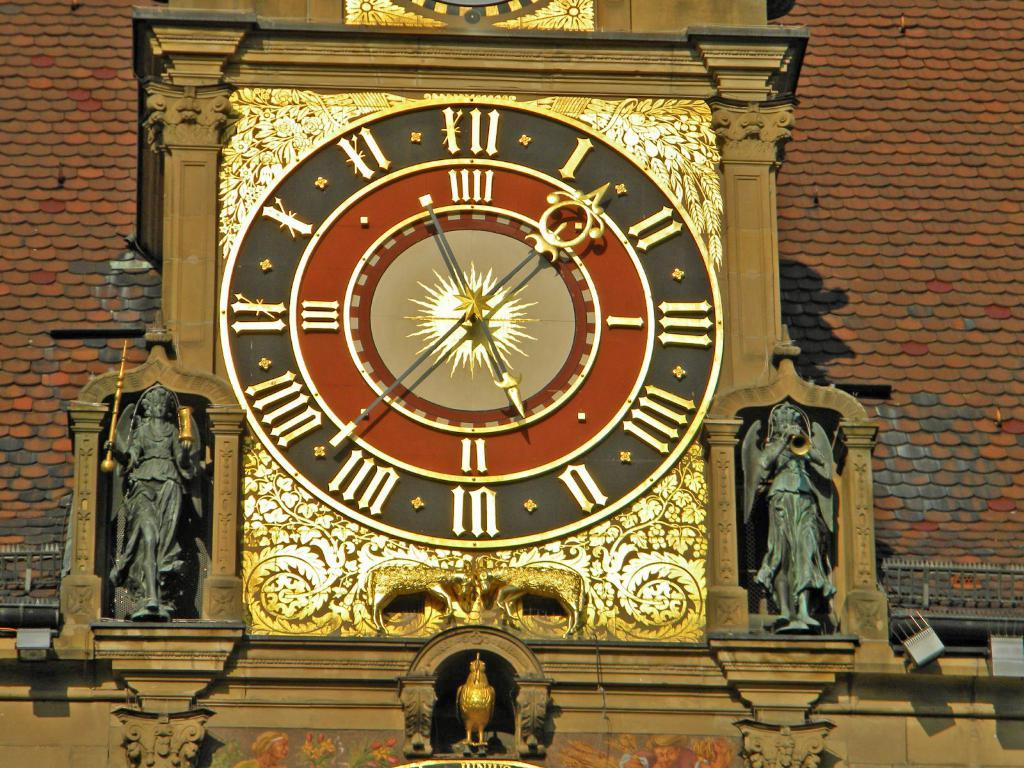<image>
Relay a brief, clear account of the picture shown. A large clock shows the time as being a little after 5:35. 